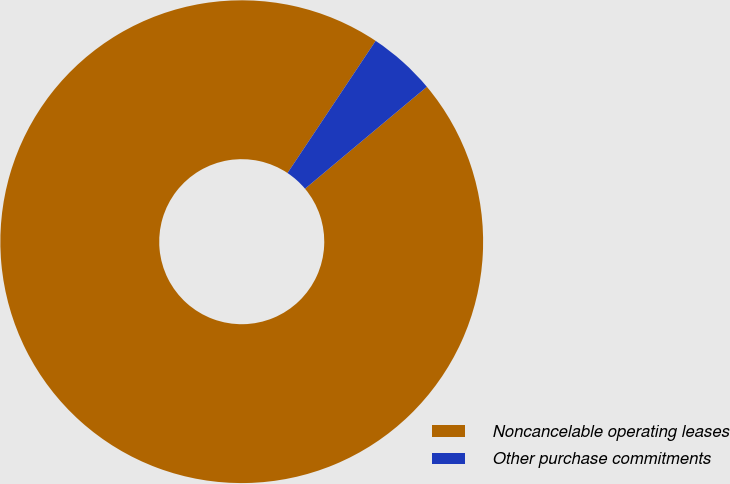<chart> <loc_0><loc_0><loc_500><loc_500><pie_chart><fcel>Noncancelable operating leases<fcel>Other purchase commitments<nl><fcel>95.45%<fcel>4.55%<nl></chart> 